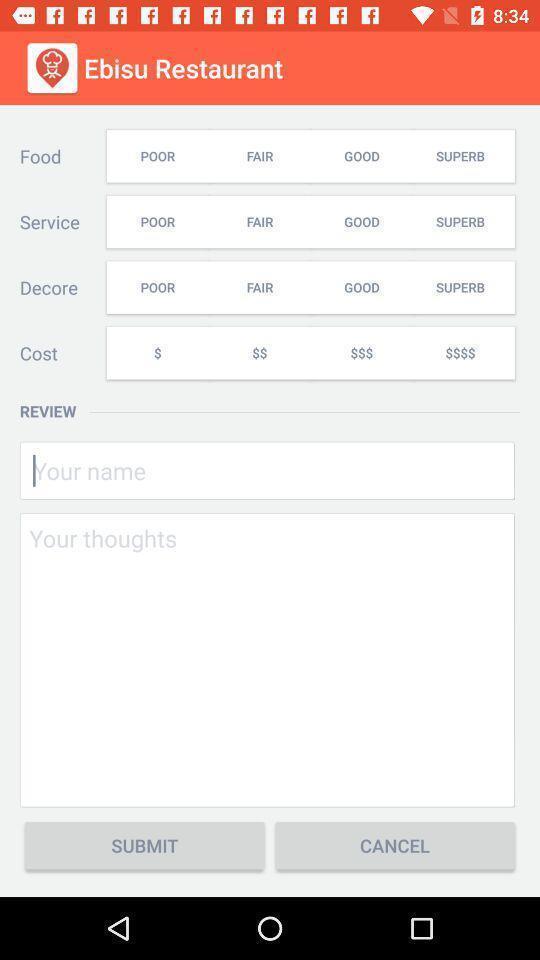Describe the visual elements of this screenshot. Screen displaying contents in feedback page. 